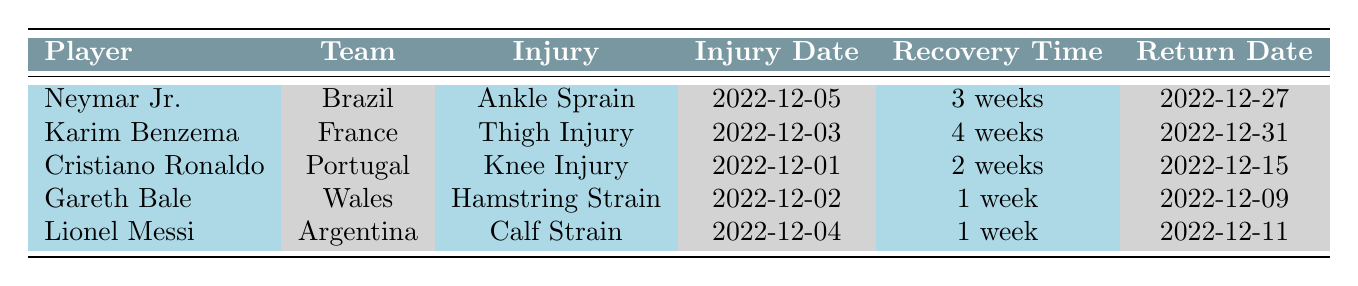What injury did Neymar Jr. sustain? The table clearly lists Neymar Jr.'s injury under the Injury column, which states "Ankle Sprain."
Answer: Ankle Sprain What was the recovery time for Karim Benzema? According to the table, Karim Benzema has a recovery time of "4 weeks" listed in the Recovery Time column.
Answer: 4 weeks Did Lionel Messi return before or after Cristiano Ronaldo? Lionel Messi's return date is December 11, while Cristiano Ronaldo's return date is December 15. Since December 11 is before December 15, Messi returned before Ronaldo.
Answer: Before What is the total recovery time for all players listed? The recovery times are as follows: Neymar Jr. (3 weeks), Karim Benzema (4 weeks), Cristiano Ronaldo (2 weeks), Gareth Bale (1 week), and Lionel Messi (1 week). Adding these gives a total of 3 + 4 + 2 + 1 + 1 = 11 weeks.
Answer: 11 weeks Which player sustained an injury first? The Injury Date column shows the initial injuries: Cristiano Ronaldo on December 1, followed by Gareth Bale on December 2, Karim Benzema on December 3, Lionel Messi on December 4, and Neymar Jr. on December 5. Since December 1 is the earliest date, Cristiano Ronaldo sustained an injury first.
Answer: Cristiano Ronaldo Did any players have a recovery time of only 1 week? Both Gareth Bale and Lionel Messi have a recovery time of "1 week," as indicated in the Recovery Time column. Thus, the answer is yes.
Answer: Yes Which player had the longest recovery time, and how long was it? From the listed recovery times, Karim Benzema has the longest recovery time of "4 weeks," as seen in the Recovery Time column.
Answer: Karim Benzema, 4 weeks What is the difference in recovery time between Neymar Jr. and Gareth Bale? Neymar Jr.'s recovery time is "3 weeks," and Gareth Bale's is "1 week." The difference is 3 weeks - 1 week = 2 weeks.
Answer: 2 weeks Which team had the player with the knee injury? The table shows that Cristiano Ronaldo, representing Portugal, had a "Knee Injury," as specified in the Injury column.
Answer: Portugal 